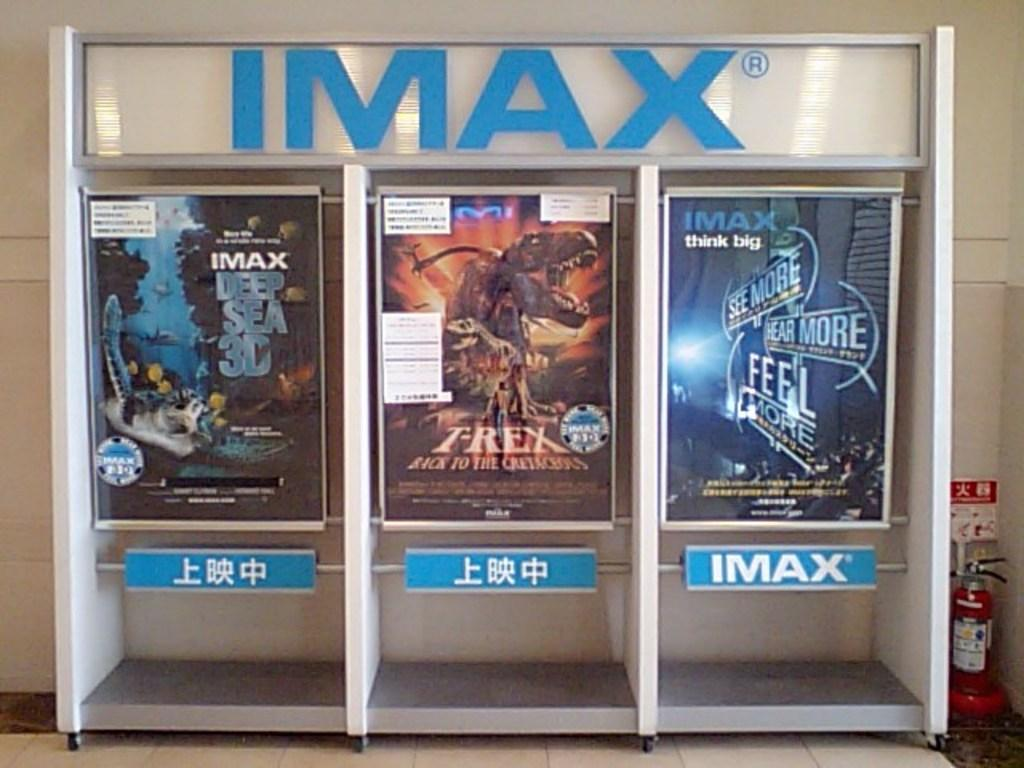Provide a one-sentence caption for the provided image. An imax advertisement with three movie posters, one being deep sea 3d. 